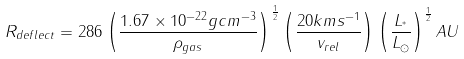<formula> <loc_0><loc_0><loc_500><loc_500>R _ { d e f l e c t } = 2 8 6 \left ( \frac { 1 . 6 7 \times 1 0 ^ { - 2 2 } g c m ^ { - 3 } } { \rho _ { g a s } } \right ) ^ { \frac { 1 } { 2 } } \left ( \frac { 2 0 k m s ^ { - 1 } } { v _ { r e l } } \right ) \left ( \frac { L _ { ^ { * } } } { L _ { \odot } } \right ) ^ { \frac { 1 } { 2 } } A U</formula> 